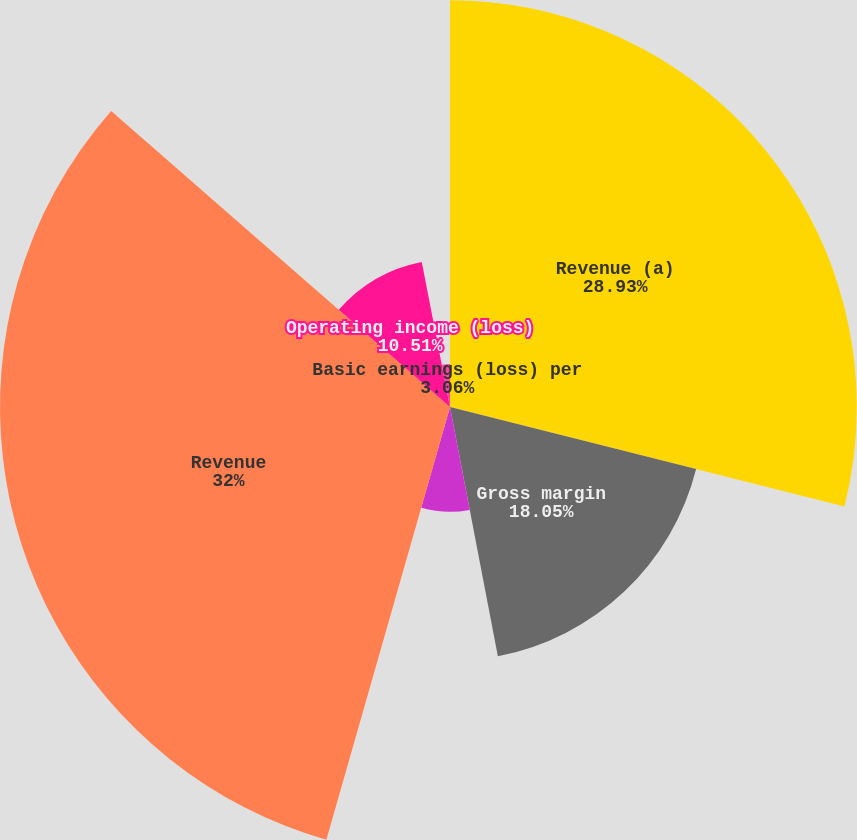Convert chart to OTSL. <chart><loc_0><loc_0><loc_500><loc_500><pie_chart><fcel>Revenue (a)<fcel>Gross margin<fcel>Operating income<fcel>Basic earnings per share<fcel>Revenue<fcel>Operating income (loss)<fcel>Basic earnings (loss) per<nl><fcel>28.93%<fcel>18.05%<fcel>7.45%<fcel>0.0%<fcel>32.0%<fcel>10.51%<fcel>3.06%<nl></chart> 